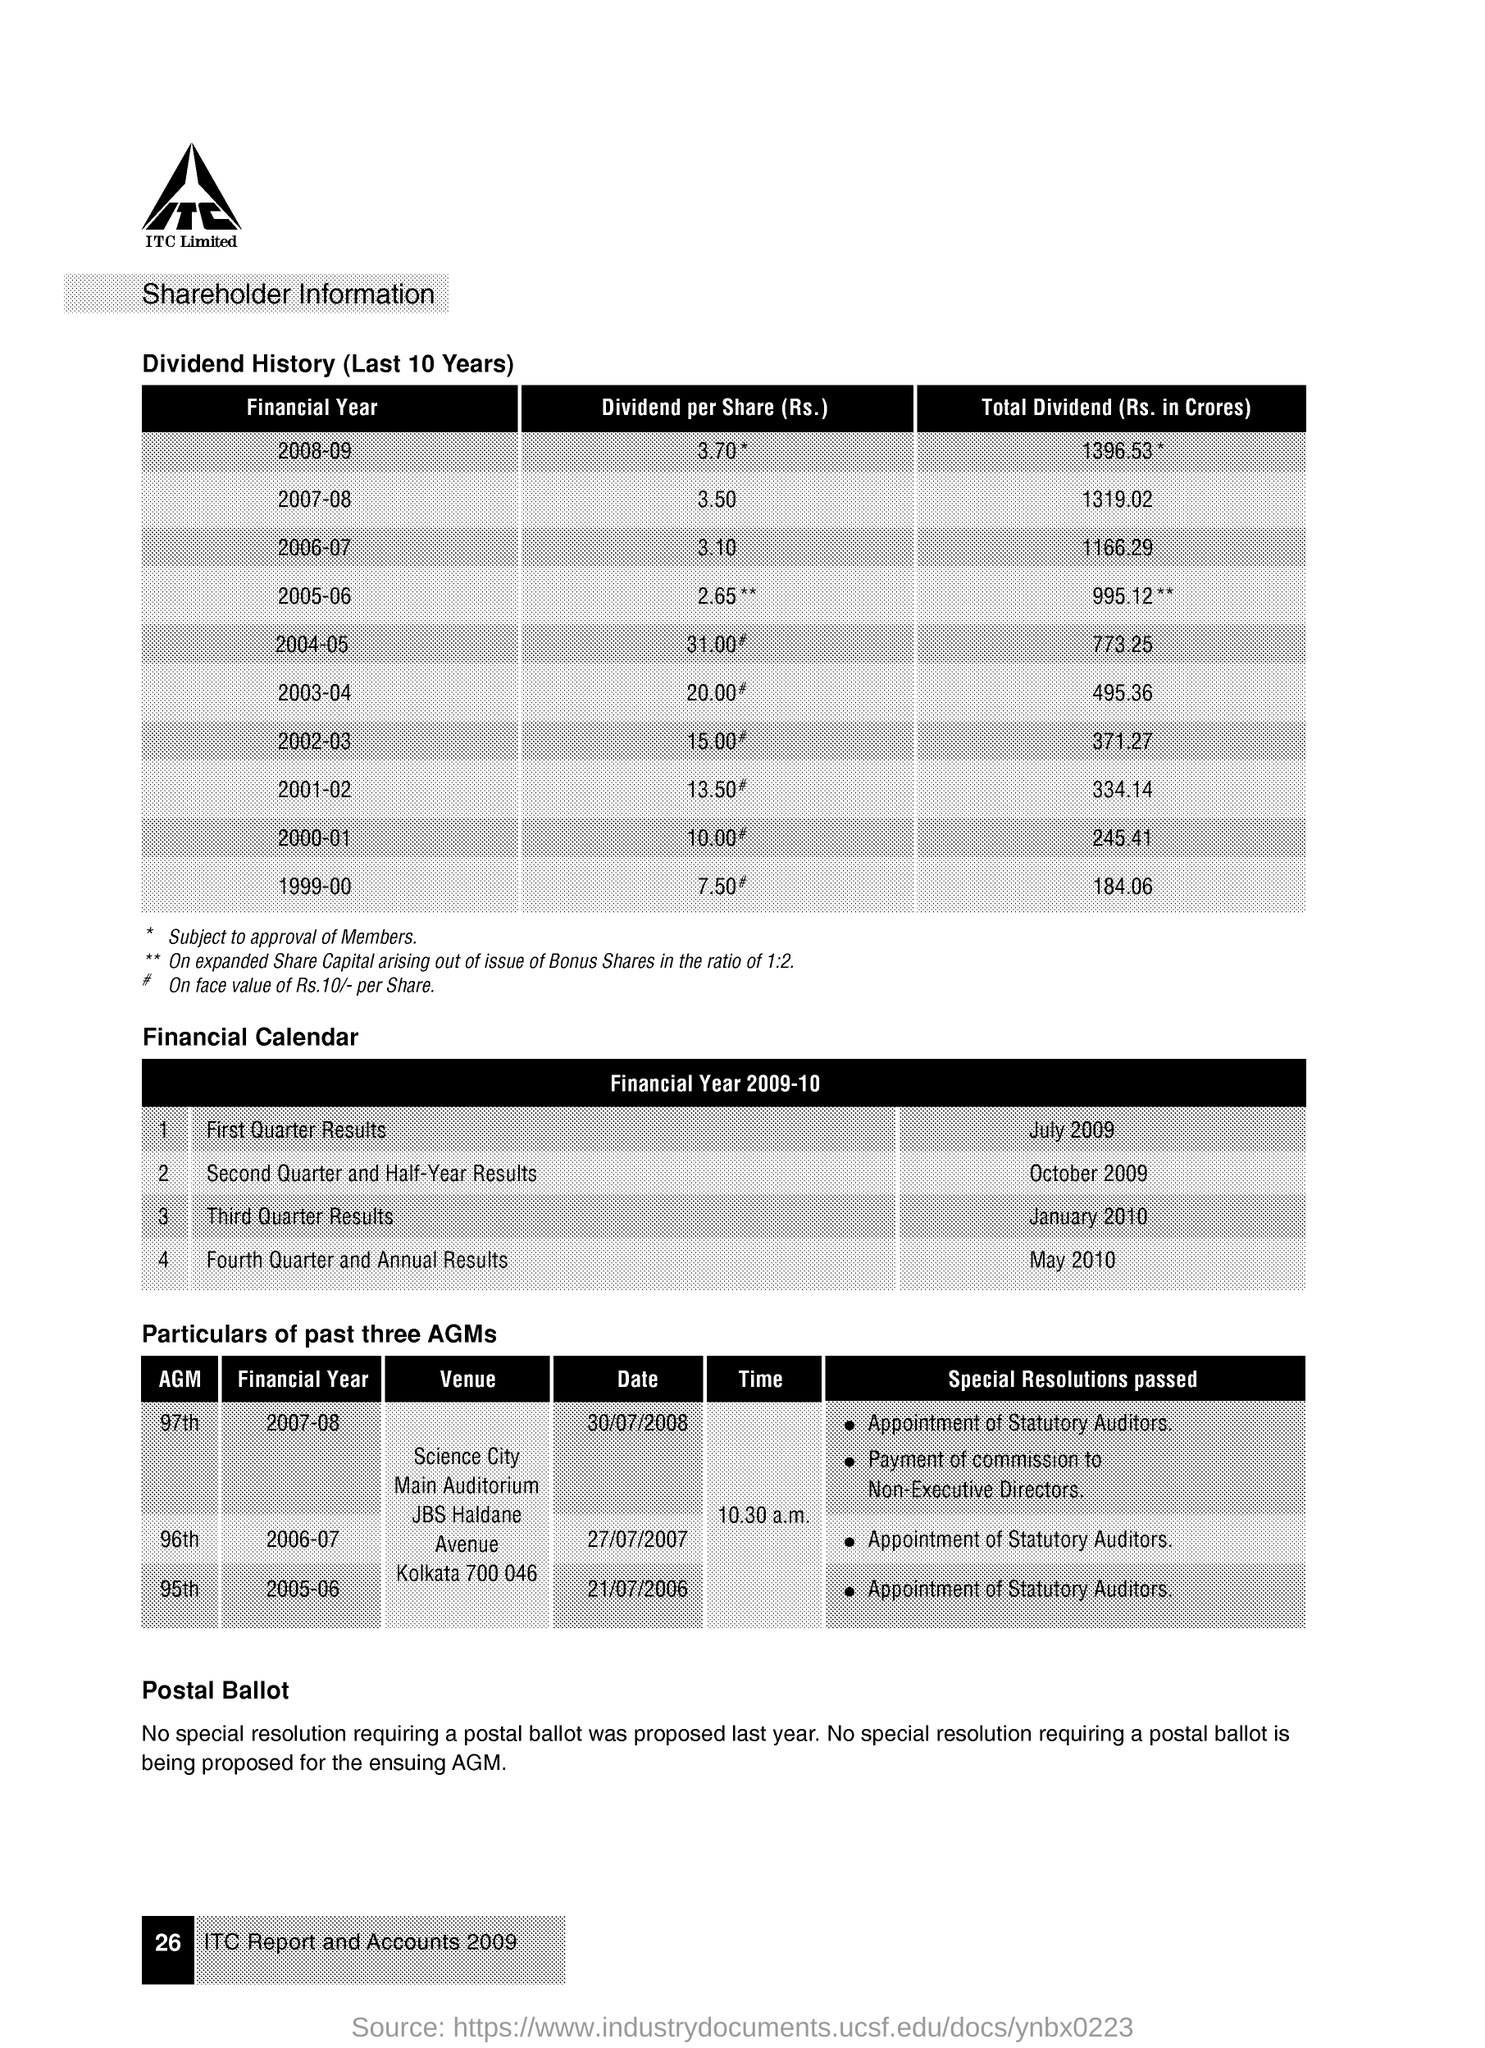in which financial year the 97th AGM was conducted ?
 2007-08 